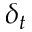Convert formula to latex. <formula><loc_0><loc_0><loc_500><loc_500>\delta _ { t }</formula> 